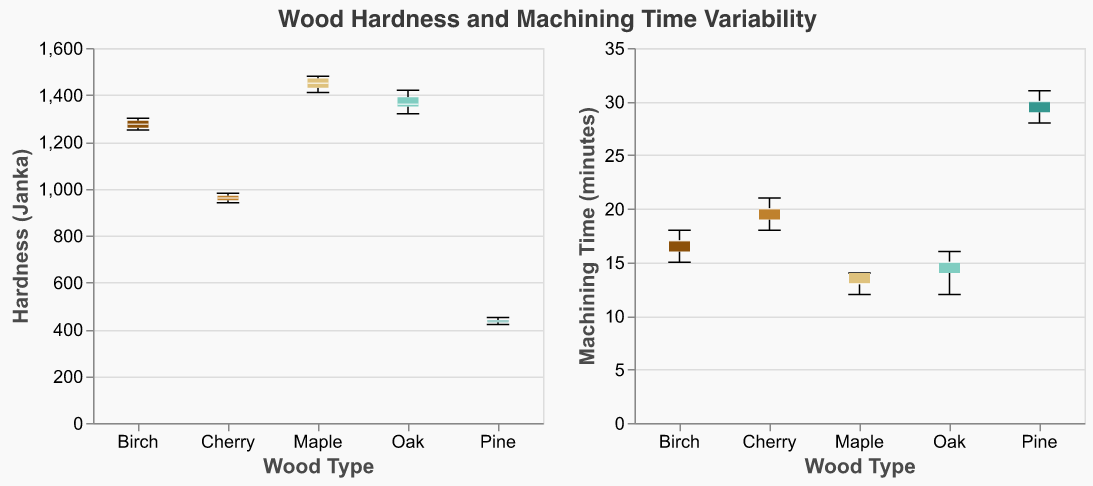What's the title of the figure? The title is shown at the top of the figure and reads "Wood Hardness and Machining Time Variability"
Answer: Wood Hardness and Machining Time Variability What is the median hardness value for Maple? By looking at the Maple box plot in the Hardness subplot, the median value lies in the center of the box. Visually, the median line appears around 1450
Answer: 1450 Which wood type has the longest median machining time? Check the median lines in the Machining Time subplot for each wood type. Pine has the highest median machining time around 30 minutes
Answer: Pine Between Oak and Birch, which has a higher median hardness? Compare the median lines in the Hardness subplot for Oak and Birch. Birch's median hardness is slightly higher than Oak's
Answer: Birch What is the range of hardness values for Pine? In the Hardness subplot, the range is shown by the whiskers of the Pine box plot. The minimum and maximum values are 420 and 450 respectively. The range is 450 - 420 = 30
Answer: 30 Which wood type shows the most variability in machining time? The variability in machining time can be seen from the height of the box and the length of the whiskers. Pine shows the most variability with whiskers extending widely around a median of 30
Answer: Pine What is the average hardness of Oak? Sum the hardness values of Oak (1360 + 1390 + 1320 + 1420 + 1350) and divide by the number of data points (5). Average = (1360 + 1390 + 1320 + 1420 + 1350) / 5 = 1368
Answer: 1368 